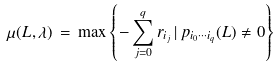<formula> <loc_0><loc_0><loc_500><loc_500>\mu ( L , \lambda ) \, = \, \max \left \{ - \sum _ { j = 0 } ^ { q } r _ { i _ { j } } \, | \, p _ { i _ { 0 } \cdots i _ { q } } ( L ) \neq 0 \right \}</formula> 